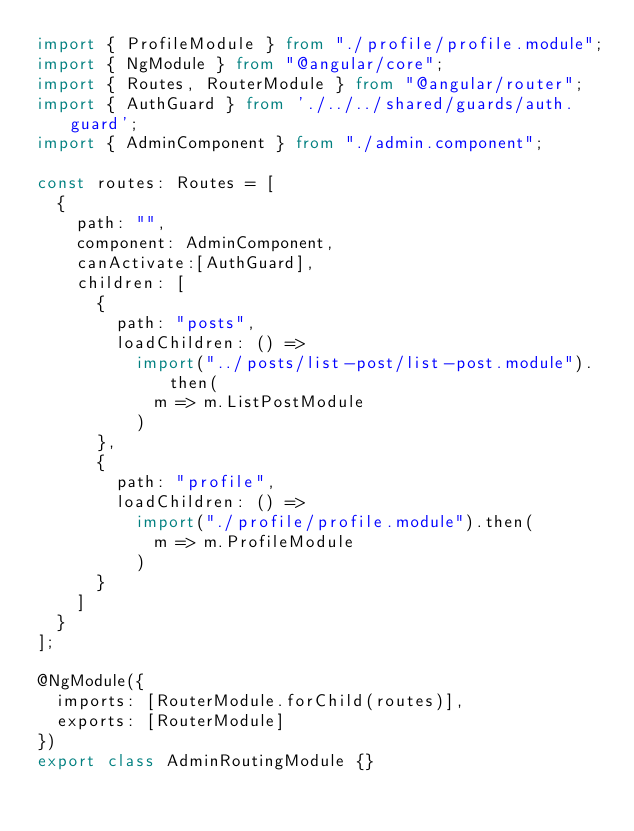<code> <loc_0><loc_0><loc_500><loc_500><_TypeScript_>import { ProfileModule } from "./profile/profile.module";
import { NgModule } from "@angular/core";
import { Routes, RouterModule } from "@angular/router";
import { AuthGuard } from './../../shared/guards/auth.guard';
import { AdminComponent } from "./admin.component";

const routes: Routes = [
  {
    path: "",
    component: AdminComponent,
    canActivate:[AuthGuard],
    children: [
      {
        path: "posts",
        loadChildren: () =>
          import("../posts/list-post/list-post.module").then(
            m => m.ListPostModule
          )
      },
      {
        path: "profile",
        loadChildren: () =>
          import("./profile/profile.module").then(
            m => m.ProfileModule
          )
      }
    ]
  }
];

@NgModule({
  imports: [RouterModule.forChild(routes)],
  exports: [RouterModule]
})
export class AdminRoutingModule {}
</code> 